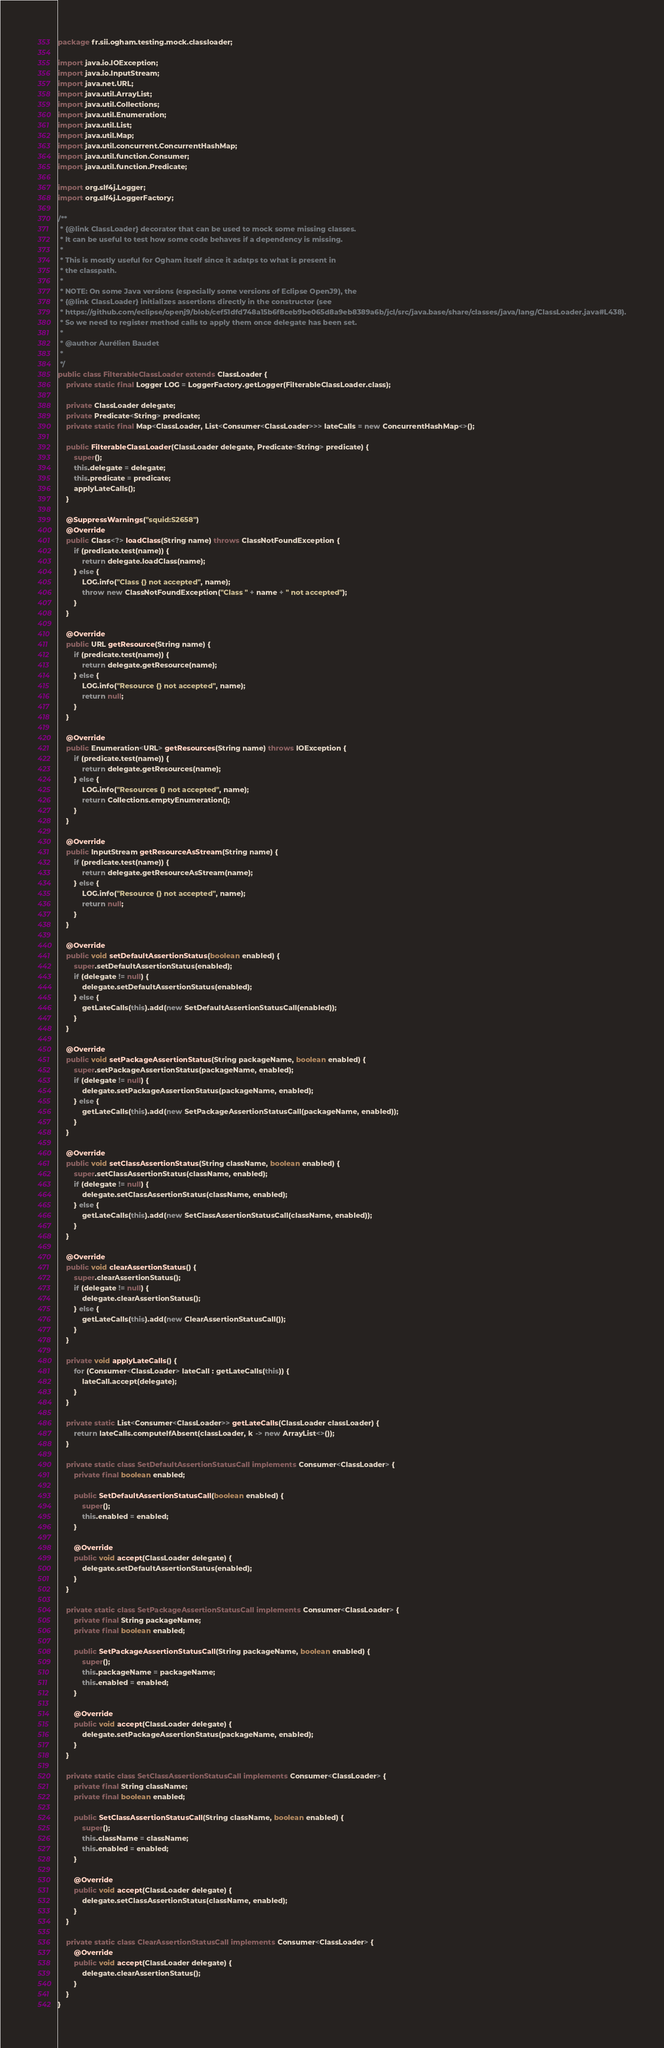Convert code to text. <code><loc_0><loc_0><loc_500><loc_500><_Java_>package fr.sii.ogham.testing.mock.classloader;

import java.io.IOException;
import java.io.InputStream;
import java.net.URL;
import java.util.ArrayList;
import java.util.Collections;
import java.util.Enumeration;
import java.util.List;
import java.util.Map;
import java.util.concurrent.ConcurrentHashMap;
import java.util.function.Consumer;
import java.util.function.Predicate;

import org.slf4j.Logger;
import org.slf4j.LoggerFactory;

/**
 * {@link ClassLoader} decorator that can be used to mock some missing classes.
 * It can be useful to test how some code behaves if a dependency is missing.
 * 
 * This is mostly useful for Ogham itself since it adatps to what is present in
 * the classpath.
 * 
 * NOTE: On some Java versions (especially some versions of Eclipse OpenJ9), the
 * {@link ClassLoader} initializes assertions directly in the constructor (see
 * https://github.com/eclipse/openj9/blob/cef51dfd748a15b6f8ceb9be065d8a9eb8389a6b/jcl/src/java.base/share/classes/java/lang/ClassLoader.java#L438).
 * So we need to register method calls to apply them once delegate has been set.
 * 
 * @author Aurélien Baudet
 *
 */
public class FilterableClassLoader extends ClassLoader {
	private static final Logger LOG = LoggerFactory.getLogger(FilterableClassLoader.class);

	private ClassLoader delegate;
	private Predicate<String> predicate;
	private static final Map<ClassLoader, List<Consumer<ClassLoader>>> lateCalls = new ConcurrentHashMap<>();

	public FilterableClassLoader(ClassLoader delegate, Predicate<String> predicate) {
		super();
		this.delegate = delegate;
		this.predicate = predicate;
		applyLateCalls();
	}

	@SuppressWarnings("squid:S2658")
	@Override
	public Class<?> loadClass(String name) throws ClassNotFoundException {
		if (predicate.test(name)) {
			return delegate.loadClass(name);
		} else {
			LOG.info("Class {} not accepted", name);
			throw new ClassNotFoundException("Class " + name + " not accepted");
		}
	}

	@Override
	public URL getResource(String name) {
		if (predicate.test(name)) {
			return delegate.getResource(name);
		} else {
			LOG.info("Resource {} not accepted", name);
			return null;
		}
	}

	@Override
	public Enumeration<URL> getResources(String name) throws IOException {
		if (predicate.test(name)) {
			return delegate.getResources(name);
		} else {
			LOG.info("Resources {} not accepted", name);
			return Collections.emptyEnumeration();
		}
	}

	@Override
	public InputStream getResourceAsStream(String name) {
		if (predicate.test(name)) {
			return delegate.getResourceAsStream(name);
		} else {
			LOG.info("Resource {} not accepted", name);
			return null;
		}
	}

	@Override
	public void setDefaultAssertionStatus(boolean enabled) {
		super.setDefaultAssertionStatus(enabled);
		if (delegate != null) {
			delegate.setDefaultAssertionStatus(enabled);
		} else {
			getLateCalls(this).add(new SetDefaultAssertionStatusCall(enabled));
		}
	}

	@Override
	public void setPackageAssertionStatus(String packageName, boolean enabled) {
		super.setPackageAssertionStatus(packageName, enabled);
		if (delegate != null) {
			delegate.setPackageAssertionStatus(packageName, enabled);
		} else {
			getLateCalls(this).add(new SetPackageAssertionStatusCall(packageName, enabled));
		}
	}

	@Override
	public void setClassAssertionStatus(String className, boolean enabled) {
		super.setClassAssertionStatus(className, enabled);
		if (delegate != null) {
			delegate.setClassAssertionStatus(className, enabled);
		} else {
			getLateCalls(this).add(new SetClassAssertionStatusCall(className, enabled));
		}
	}

	@Override
	public void clearAssertionStatus() {
		super.clearAssertionStatus();
		if (delegate != null) {
			delegate.clearAssertionStatus();
		} else {
			getLateCalls(this).add(new ClearAssertionStatusCall());
		}
	}

	private void applyLateCalls() {
		for (Consumer<ClassLoader> lateCall : getLateCalls(this)) {
			lateCall.accept(delegate);
		}
	}

	private static List<Consumer<ClassLoader>> getLateCalls(ClassLoader classLoader) {
		return lateCalls.computeIfAbsent(classLoader, k -> new ArrayList<>());
	}

	private static class SetDefaultAssertionStatusCall implements Consumer<ClassLoader> {
		private final boolean enabled;

		public SetDefaultAssertionStatusCall(boolean enabled) {
			super();
			this.enabled = enabled;
		}

		@Override
		public void accept(ClassLoader delegate) {
			delegate.setDefaultAssertionStatus(enabled);
		}
	}

	private static class SetPackageAssertionStatusCall implements Consumer<ClassLoader> {
		private final String packageName;
		private final boolean enabled;

		public SetPackageAssertionStatusCall(String packageName, boolean enabled) {
			super();
			this.packageName = packageName;
			this.enabled = enabled;
		}

		@Override
		public void accept(ClassLoader delegate) {
			delegate.setPackageAssertionStatus(packageName, enabled);
		}
	}

	private static class SetClassAssertionStatusCall implements Consumer<ClassLoader> {
		private final String className;
		private final boolean enabled;

		public SetClassAssertionStatusCall(String className, boolean enabled) {
			super();
			this.className = className;
			this.enabled = enabled;
		}

		@Override
		public void accept(ClassLoader delegate) {
			delegate.setClassAssertionStatus(className, enabled);
		}
	}

	private static class ClearAssertionStatusCall implements Consumer<ClassLoader> {
		@Override
		public void accept(ClassLoader delegate) {
			delegate.clearAssertionStatus();
		}
	}
}
</code> 